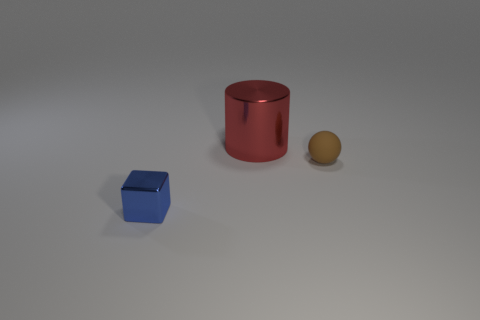Add 3 matte spheres. How many objects exist? 6 Subtract all blocks. How many objects are left? 2 Add 2 small cubes. How many small cubes exist? 3 Subtract 1 blue cubes. How many objects are left? 2 Subtract all big metal things. Subtract all rubber spheres. How many objects are left? 1 Add 1 tiny brown objects. How many tiny brown objects are left? 2 